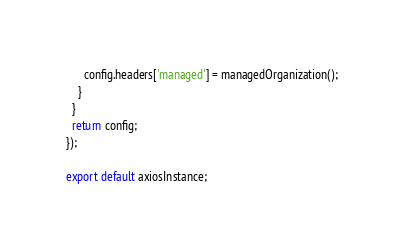Convert code to text. <code><loc_0><loc_0><loc_500><loc_500><_JavaScript_>      config.headers['managed'] = managedOrganization();
    }
  }
  return config;
});

export default axiosInstance;
</code> 